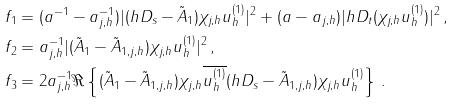Convert formula to latex. <formula><loc_0><loc_0><loc_500><loc_500>f _ { 1 } & = ( a ^ { - 1 } - a _ { j , h } ^ { - 1 } ) | ( h D _ { s } - \tilde { A } _ { 1 } ) \chi _ { j , h } u _ { h } ^ { ( 1 ) } | ^ { 2 } + ( a - a _ { j , h } ) | h D _ { t } ( \chi _ { j , h } u _ { h } ^ { ( 1 ) } ) | ^ { 2 } \, , \\ f _ { 2 } & = a _ { j , h } ^ { - 1 } | ( \tilde { A } _ { 1 } - \tilde { A } _ { 1 , j , h } ) \chi _ { j , h } u _ { h } ^ { ( 1 ) } | ^ { 2 } \, , \\ f _ { 3 } & = 2 a _ { j , h } ^ { - 1 } \Re \left \{ ( \tilde { A } _ { 1 } - \tilde { A } _ { 1 , j , h } ) \chi _ { j , h } \overline { u _ { h } ^ { ( 1 ) } } ( h D _ { s } - \tilde { A } _ { 1 , j , h } ) \chi _ { j , h } u _ { h } ^ { ( 1 ) } \right \} \, .</formula> 